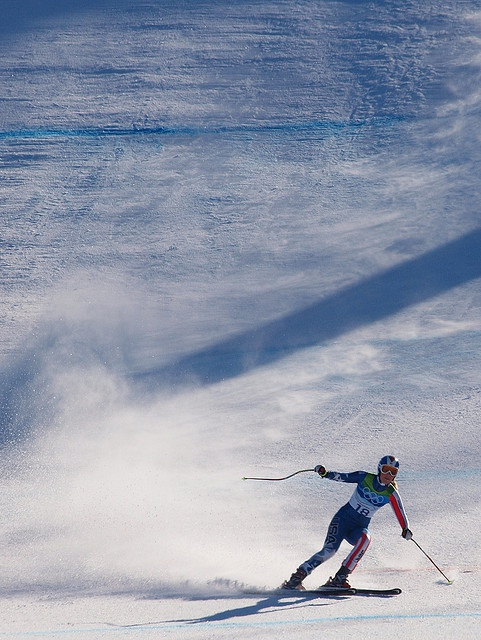Describe the objects in this image and their specific colors. I can see people in blue, black, navy, and gray tones and skis in blue, black, gray, darkblue, and navy tones in this image. 